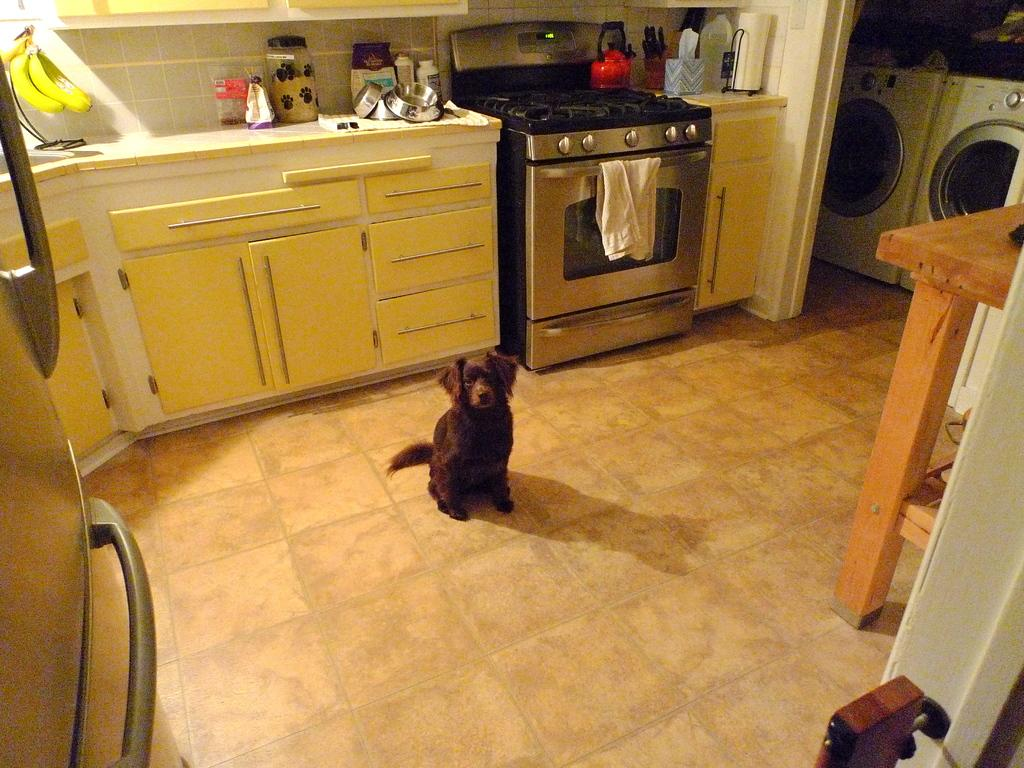What type of appliance is present in the image? There is a washing machine in the image. What is the dog doing in the image? The dog is on the floor in the image. What else can be seen in the image besides the washing machine and the dog? There is a gas in the image. Where is the harbor located in the image? There is no harbor present in the image. Is the dog getting a haircut in the image? There is no indication in the image that the dog is getting a haircut. Can you see an argument taking place between two people in the image? There are no people present in the image, so it is not possible to see an argument. 